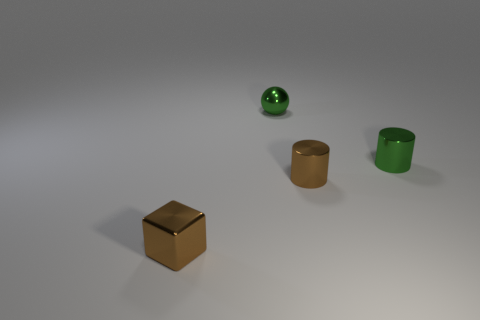What material is the green cylinder that is the same size as the metal sphere?
Your answer should be compact. Metal. Is there a blue cube of the same size as the brown metal cube?
Offer a terse response. No. Is the number of shiny objects right of the ball less than the number of brown shiny blocks?
Offer a very short reply. No. Is the number of shiny balls to the right of the tiny ball less than the number of small shiny blocks behind the small brown cylinder?
Your answer should be compact. No. How many blocks are small brown shiny things or small shiny things?
Make the answer very short. 1. Are the small green thing that is right of the brown cylinder and the tiny brown thing that is behind the shiny cube made of the same material?
Your answer should be very brief. Yes. What shape is the green shiny thing that is the same size as the shiny ball?
Your answer should be compact. Cylinder. What number of other objects are the same color as the small cube?
Ensure brevity in your answer.  1. What number of gray things are either metallic cubes or balls?
Your answer should be compact. 0. Do the brown shiny thing to the right of the tiny green shiny sphere and the small green metal thing behind the small green shiny cylinder have the same shape?
Offer a terse response. No. 